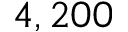<formula> <loc_0><loc_0><loc_500><loc_500>4 , 2 0 0</formula> 